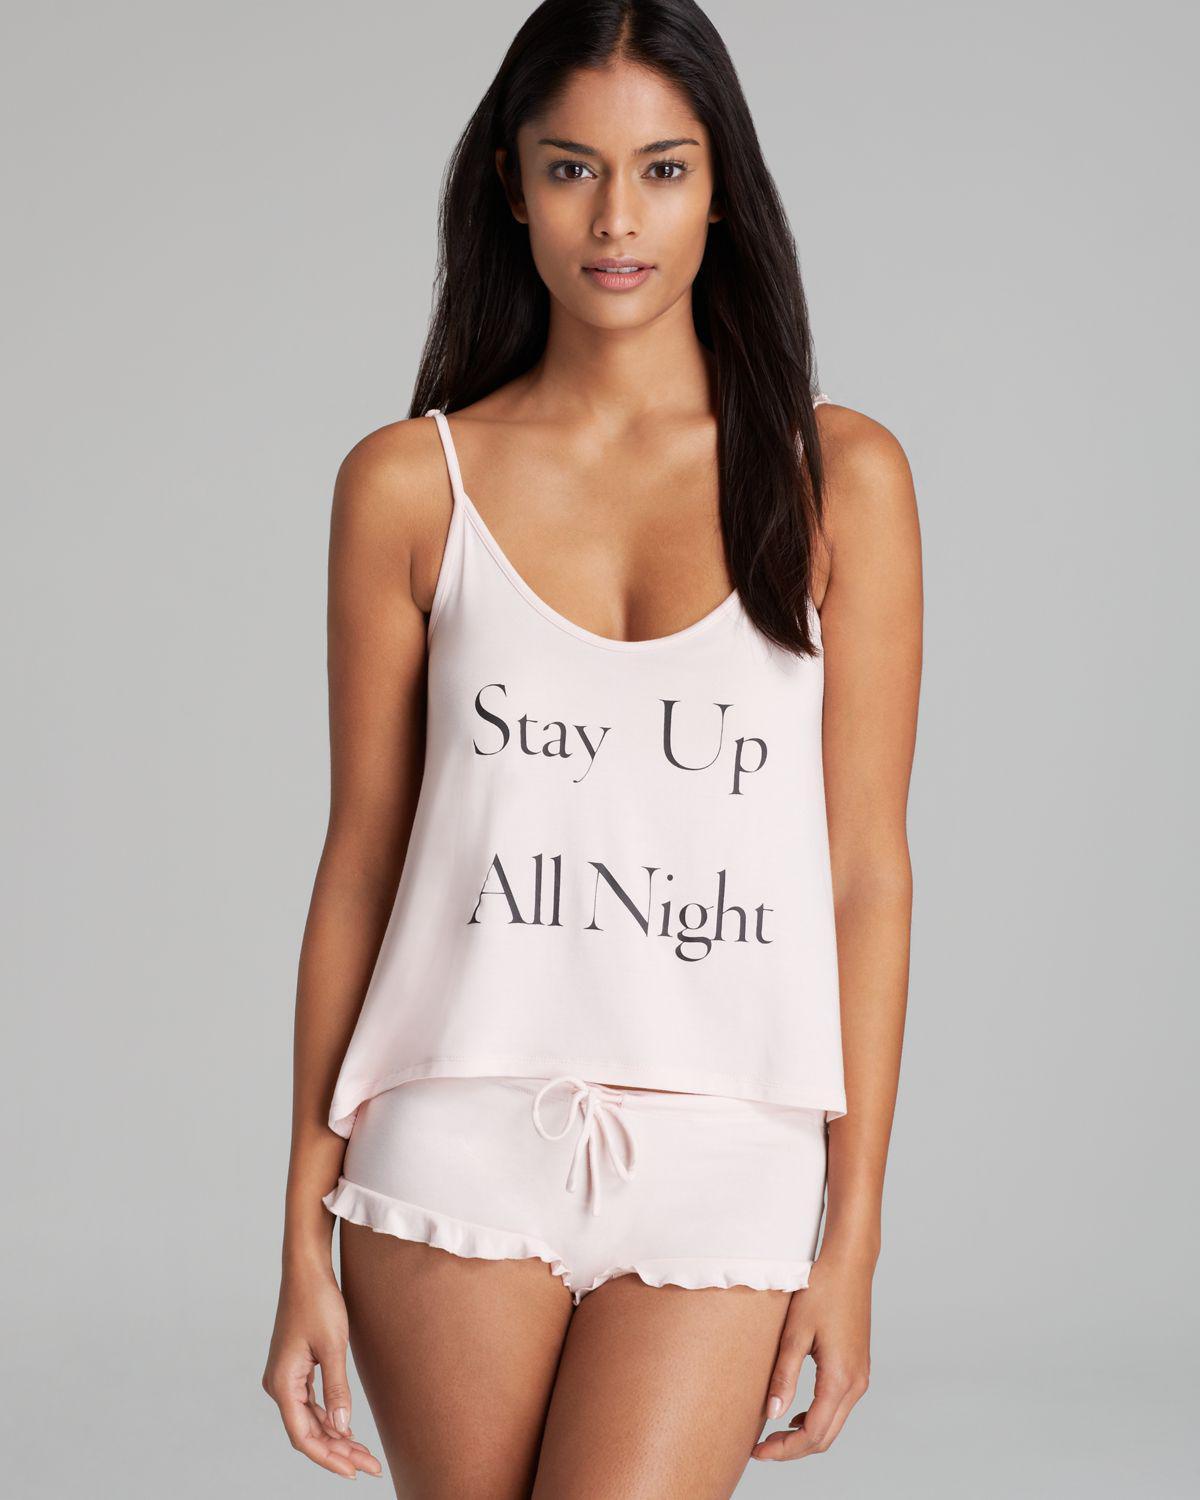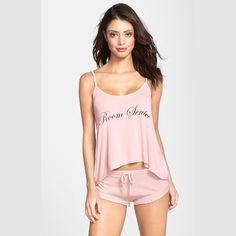The first image is the image on the left, the second image is the image on the right. Assess this claim about the two images: "There is a woman wearing a pajama top with no sleeves and a pair of pajama shorts.". Correct or not? Answer yes or no. Yes. The first image is the image on the left, the second image is the image on the right. Given the left and right images, does the statement "Left and right images feature models wearing same style outfits." hold true? Answer yes or no. Yes. 